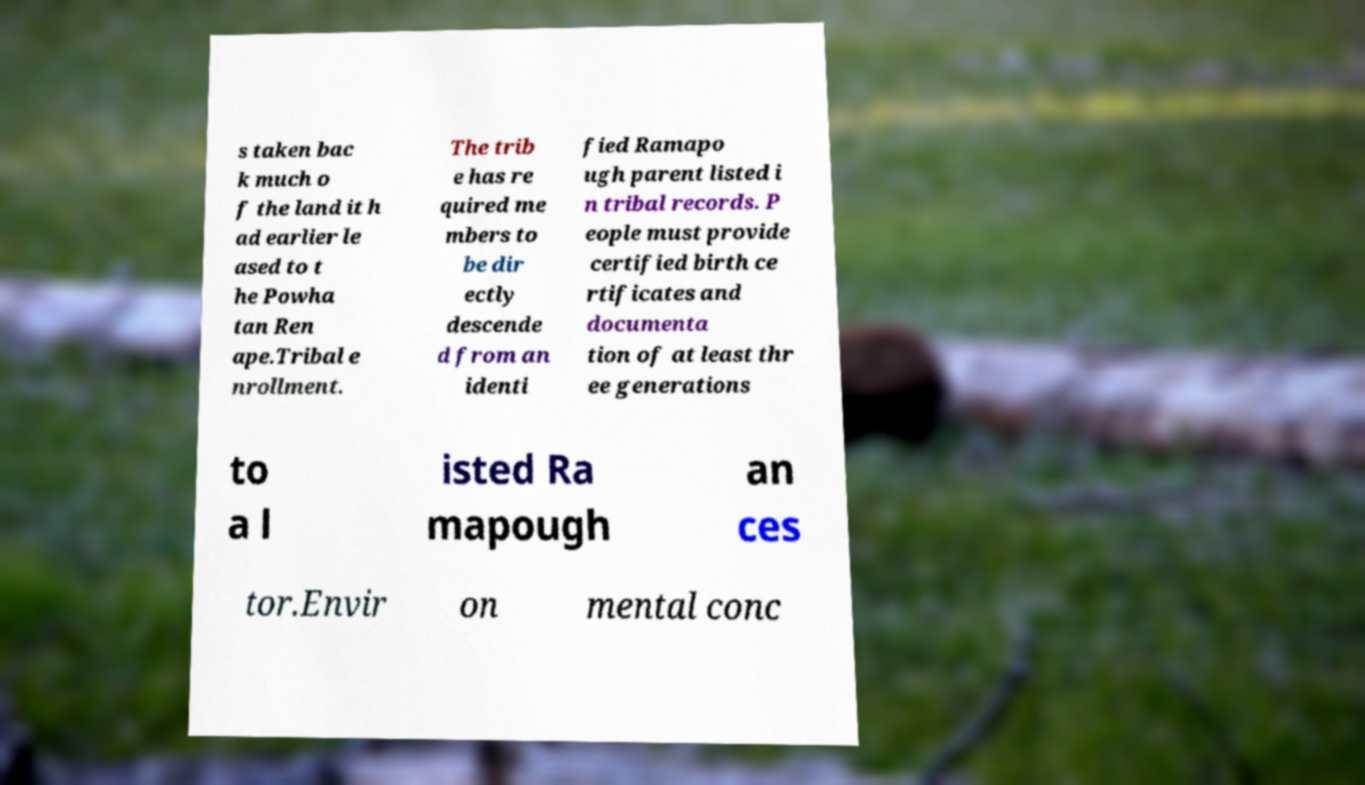Please read and relay the text visible in this image. What does it say? s taken bac k much o f the land it h ad earlier le ased to t he Powha tan Ren ape.Tribal e nrollment. The trib e has re quired me mbers to be dir ectly descende d from an identi fied Ramapo ugh parent listed i n tribal records. P eople must provide certified birth ce rtificates and documenta tion of at least thr ee generations to a l isted Ra mapough an ces tor.Envir on mental conc 